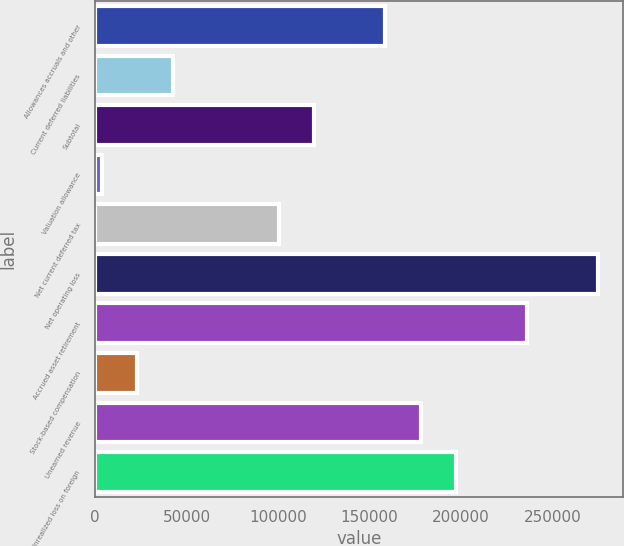Convert chart to OTSL. <chart><loc_0><loc_0><loc_500><loc_500><bar_chart><fcel>Allowances accruals and other<fcel>Current deferred liabilities<fcel>Subtotal<fcel>Valuation allowance<fcel>Net current deferred tax<fcel>Net operating loss<fcel>Accrued asset retirement<fcel>Stock-based compensation<fcel>Unearned revenue<fcel>Unrealized loss on foreign<nl><fcel>158596<fcel>42377.4<fcel>119856<fcel>3638<fcel>100486<fcel>274814<fcel>236074<fcel>23007.7<fcel>177965<fcel>197335<nl></chart> 